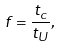<formula> <loc_0><loc_0><loc_500><loc_500>f = \frac { t _ { c } } { t _ { U } } ,</formula> 